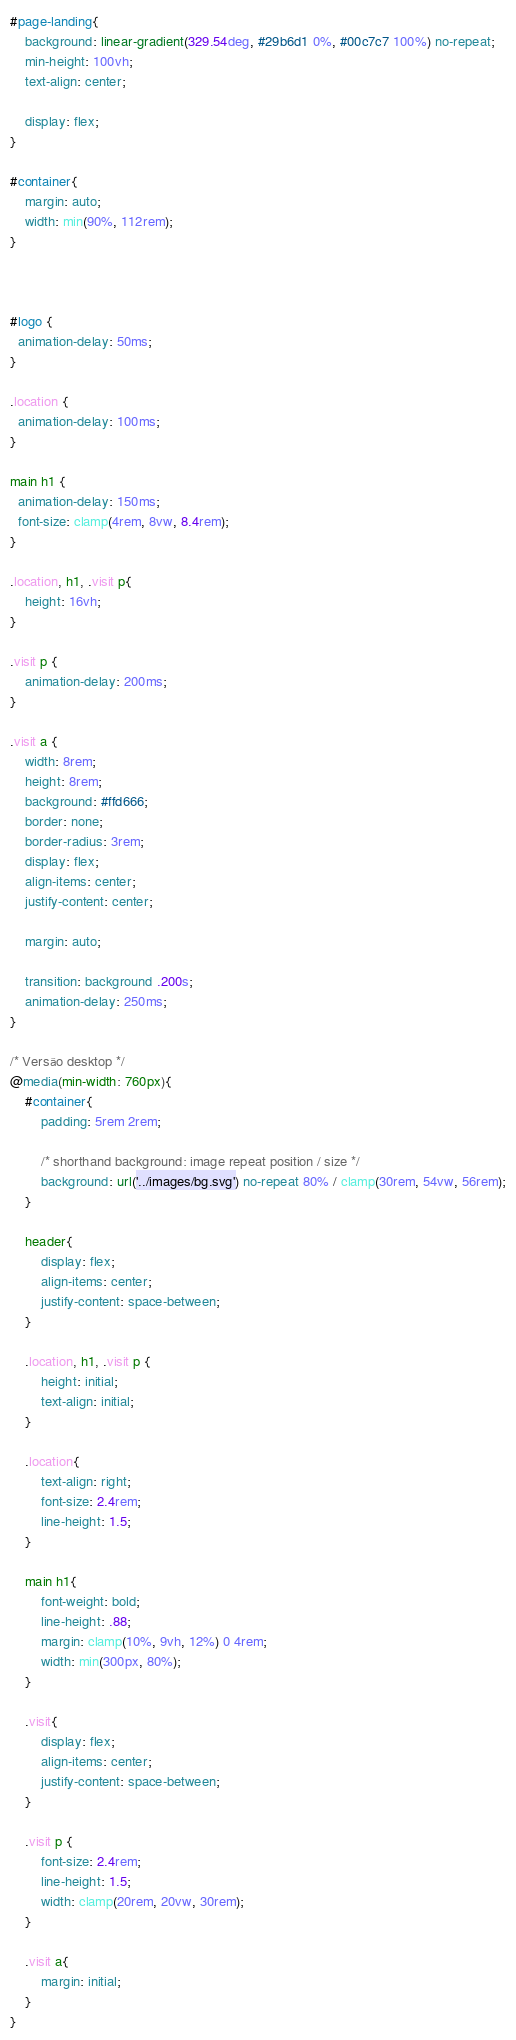Convert code to text. <code><loc_0><loc_0><loc_500><loc_500><_CSS_>
#page-landing{    
    background: linear-gradient(329.54deg, #29b6d1 0%, #00c7c7 100%) no-repeat;
    min-height: 100vh;
    text-align: center;

    display: flex;
}

#container{
    margin: auto;
    width: min(90%, 112rem);
}



#logo {
  animation-delay: 50ms;
}

.location {
  animation-delay: 100ms;
}

main h1 {
  animation-delay: 150ms;
  font-size: clamp(4rem, 8vw, 8.4rem);
}

.location, h1, .visit p{
    height: 16vh;
}

.visit p {
    animation-delay: 200ms;
}

.visit a {
    width: 8rem;
    height: 8rem;
    background: #ffd666;
    border: none;
    border-radius: 3rem;
    display: flex;
    align-items: center;
    justify-content: center;

    margin: auto;

    transition: background .200s;
    animation-delay: 250ms;
}

/* Versão desktop */
@media(min-width: 760px){
    #container{
        padding: 5rem 2rem;

        /* shorthand background: image repeat position / size */
        background: url('../images/bg.svg') no-repeat 80% / clamp(30rem, 54vw, 56rem);
    }

    header{
        display: flex;
        align-items: center;
        justify-content: space-between;
    }

    .location, h1, .visit p {
        height: initial;
        text-align: initial;
    }

    .location{
        text-align: right;
        font-size: 2.4rem;
        line-height: 1.5;
    }

    main h1{        
        font-weight: bold;
        line-height: .88;
        margin: clamp(10%, 9vh, 12%) 0 4rem;
        width: min(300px, 80%);
    }

    .visit{
        display: flex;
        align-items: center;
        justify-content: space-between;
    }

    .visit p {
        font-size: 2.4rem;
        line-height: 1.5;
        width: clamp(20rem, 20vw, 30rem);
    }

    .visit a{
        margin: initial;   
    }
}</code> 